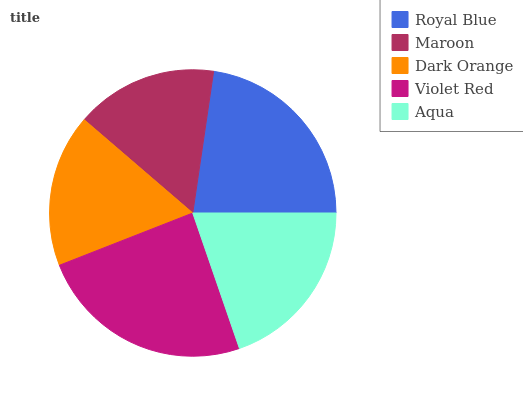Is Maroon the minimum?
Answer yes or no. Yes. Is Violet Red the maximum?
Answer yes or no. Yes. Is Dark Orange the minimum?
Answer yes or no. No. Is Dark Orange the maximum?
Answer yes or no. No. Is Dark Orange greater than Maroon?
Answer yes or no. Yes. Is Maroon less than Dark Orange?
Answer yes or no. Yes. Is Maroon greater than Dark Orange?
Answer yes or no. No. Is Dark Orange less than Maroon?
Answer yes or no. No. Is Aqua the high median?
Answer yes or no. Yes. Is Aqua the low median?
Answer yes or no. Yes. Is Maroon the high median?
Answer yes or no. No. Is Royal Blue the low median?
Answer yes or no. No. 